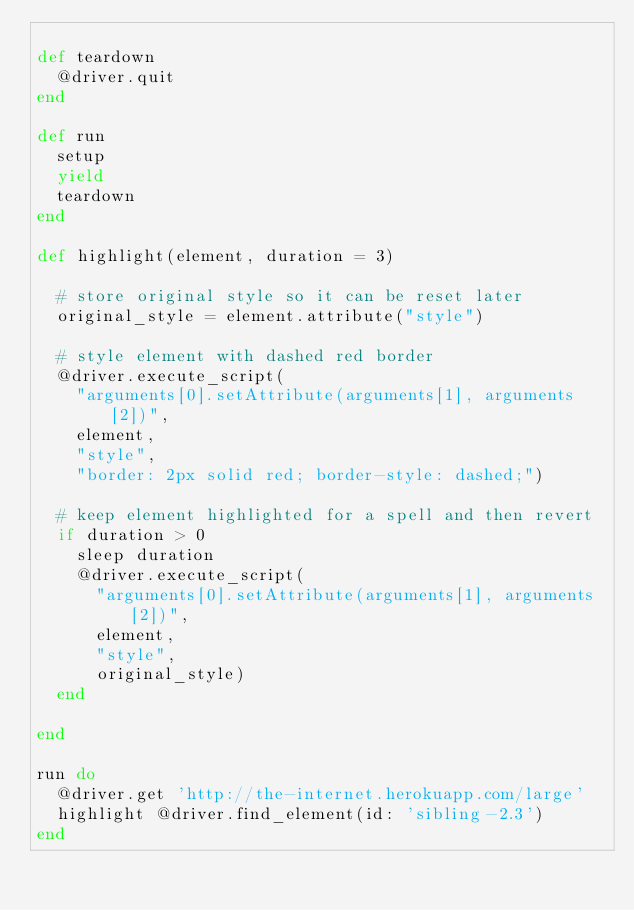Convert code to text. <code><loc_0><loc_0><loc_500><loc_500><_Ruby_>
def teardown
  @driver.quit
end

def run
  setup
  yield
  teardown
end

def highlight(element, duration = 3)

  # store original style so it can be reset later
  original_style = element.attribute("style")

  # style element with dashed red border
  @driver.execute_script(
    "arguments[0].setAttribute(arguments[1], arguments[2])",
    element,
    "style",
    "border: 2px solid red; border-style: dashed;")

  # keep element highlighted for a spell and then revert
  if duration > 0
    sleep duration
    @driver.execute_script(
      "arguments[0].setAttribute(arguments[1], arguments[2])",
      element,
      "style",
      original_style)
  end

end

run do
  @driver.get 'http://the-internet.herokuapp.com/large'
  highlight @driver.find_element(id: 'sibling-2.3')
end
</code> 